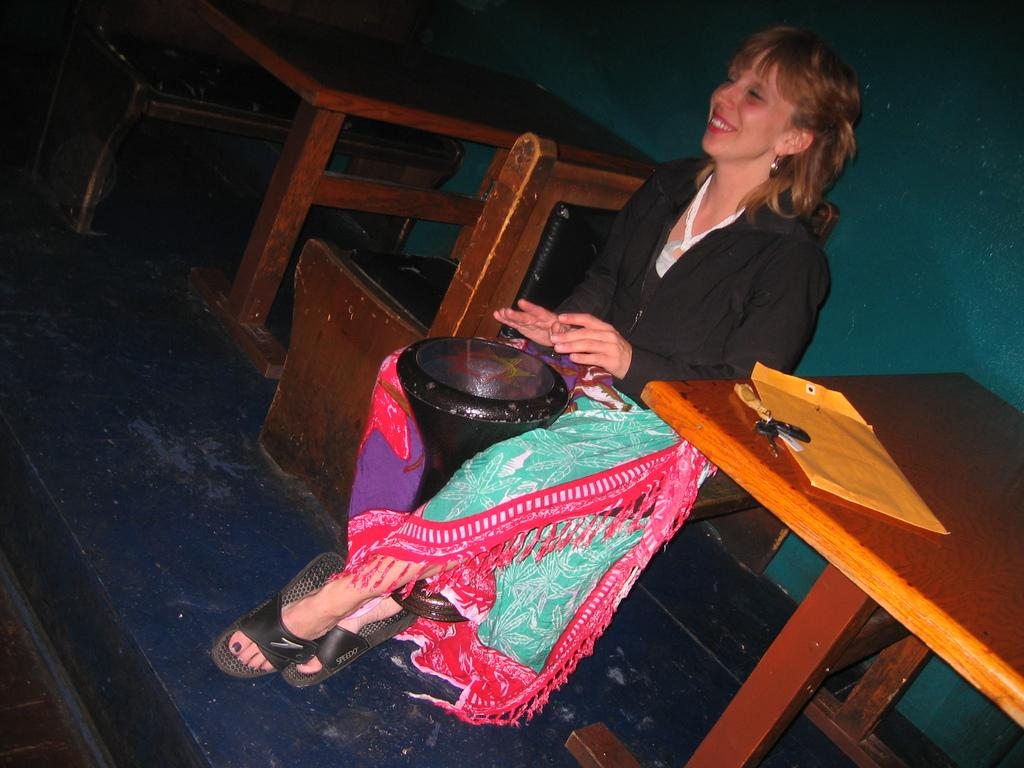Who is the main subject in the image? There is a woman in the image. What is the woman doing in the image? The woman is sitting on a bench and playing a musical instrument. What else can be seen in the image besides the woman? There are tables and chairs in the image. Where is the woman located in relation to the table? The woman is near a table. What type of rock can be seen on the table in the image? There is no rock present on the table in the image. Is the woman taking a bath in the image? No, the woman is sitting on a bench and playing a musical instrument, not taking a bath. 